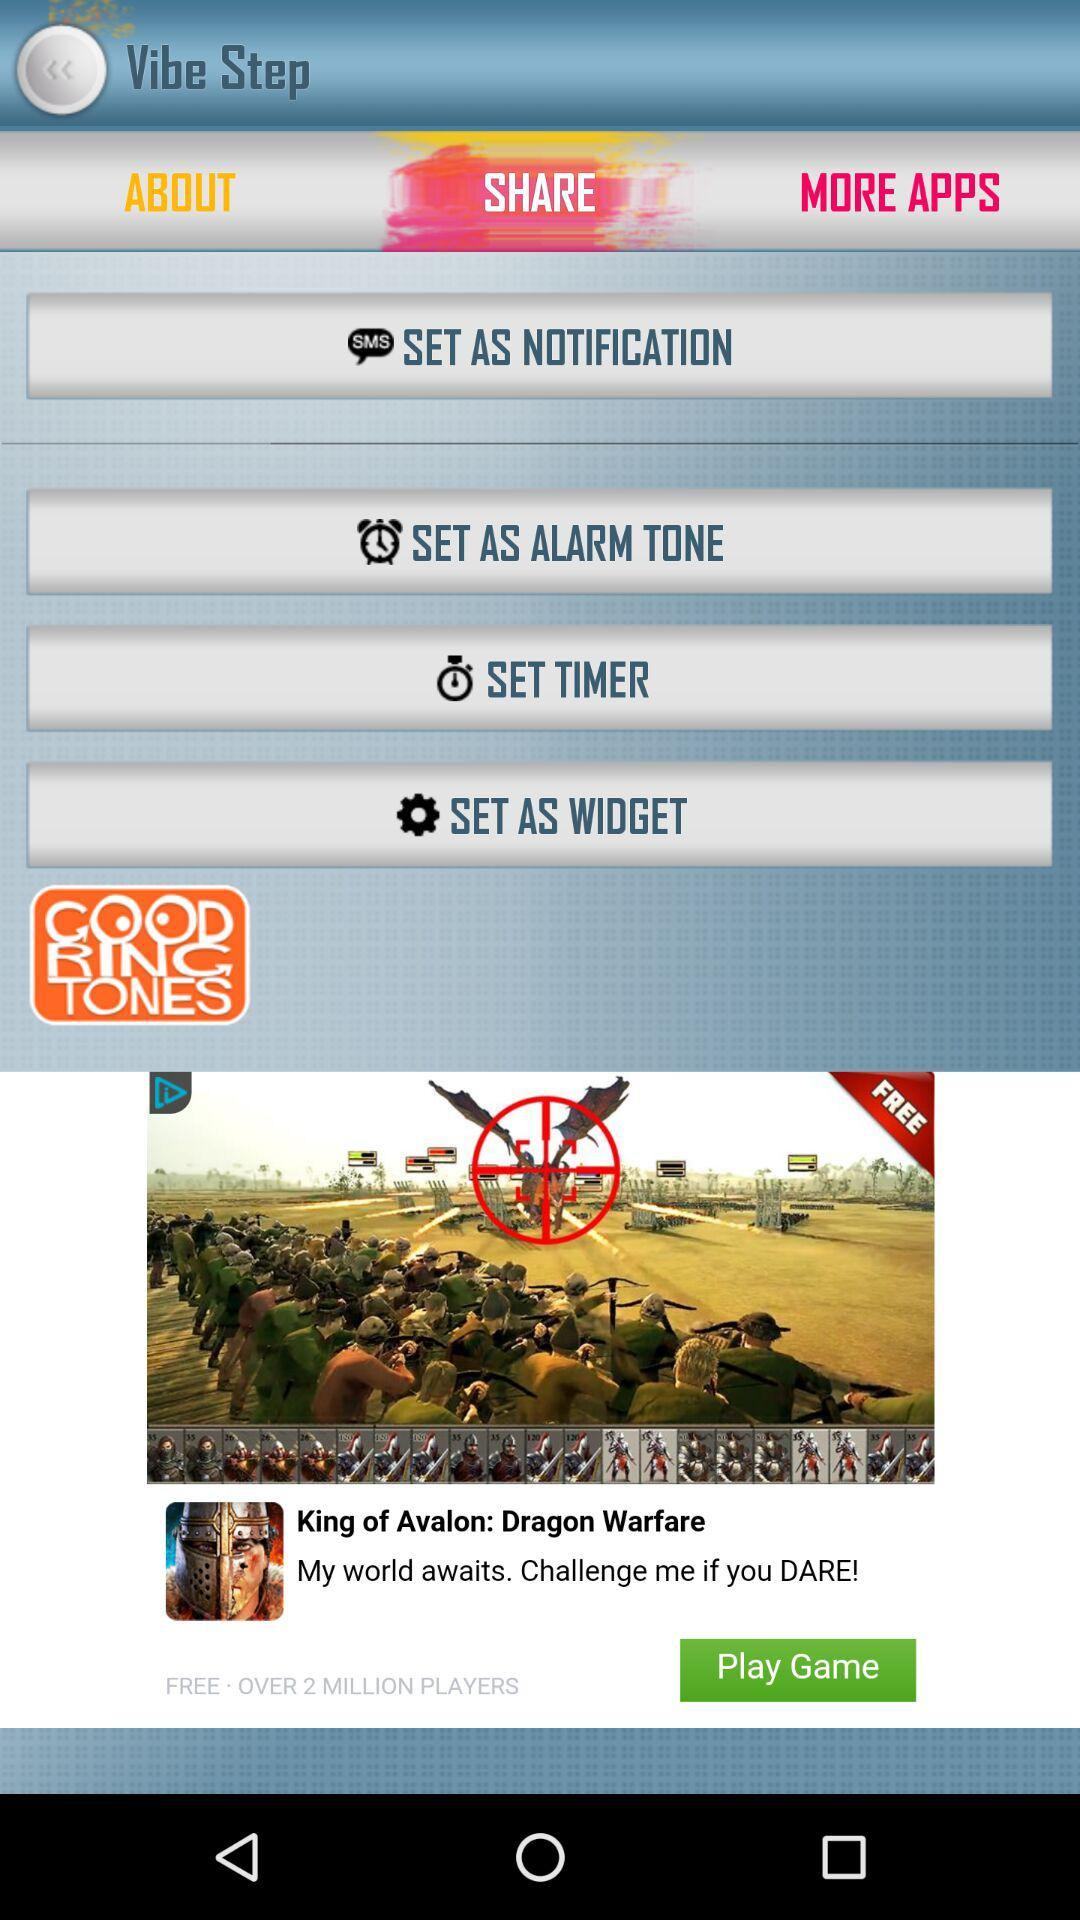What is the application name? The name of the application is "GOODRINGTONES". 